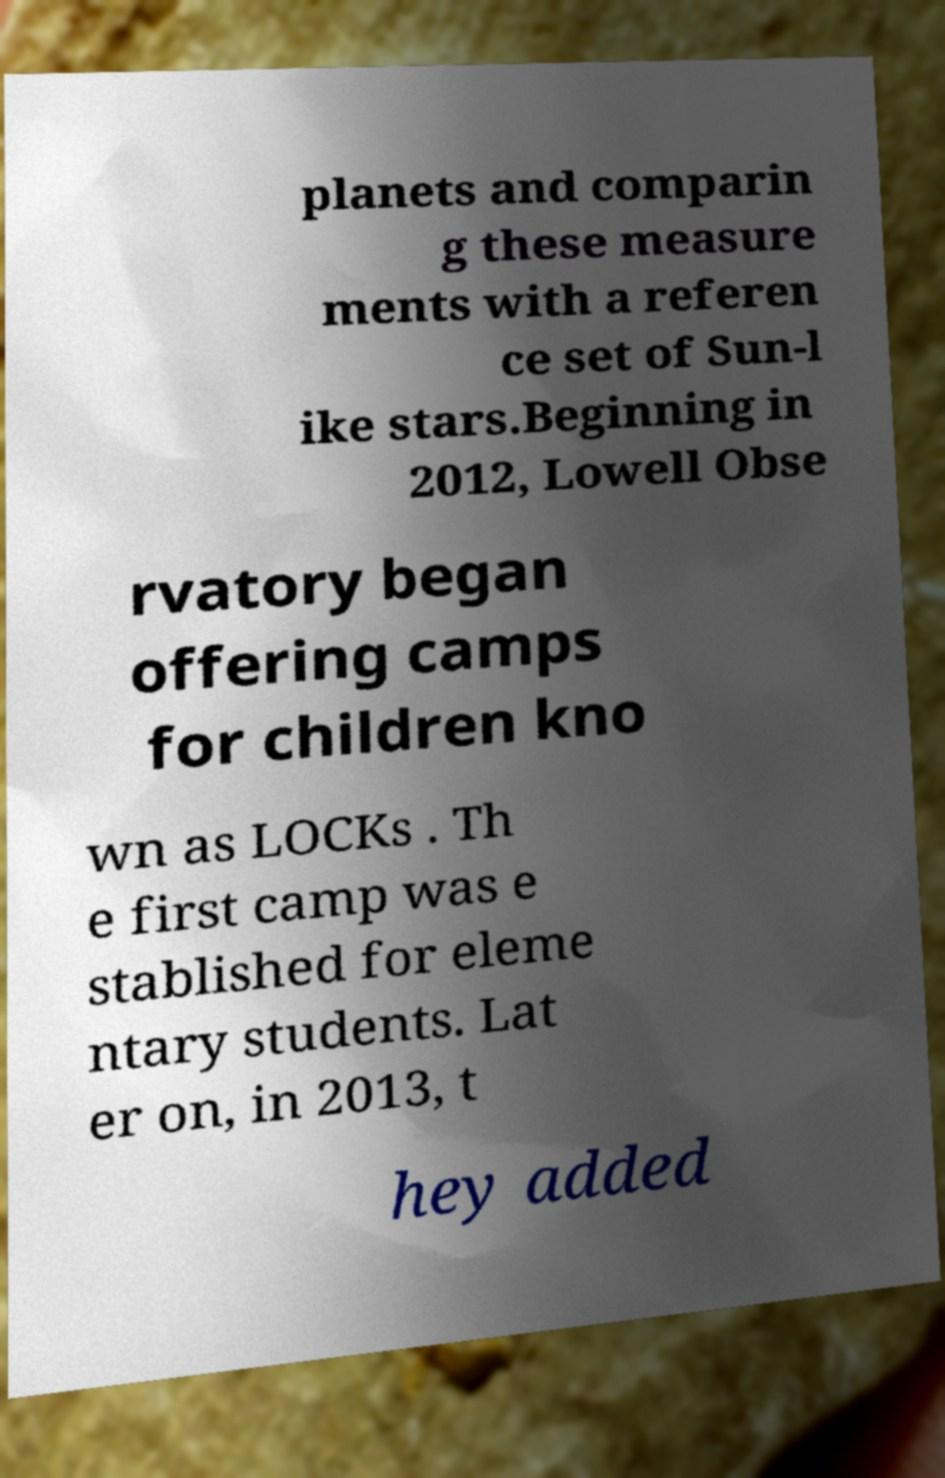Could you assist in decoding the text presented in this image and type it out clearly? planets and comparin g these measure ments with a referen ce set of Sun-l ike stars.Beginning in 2012, Lowell Obse rvatory began offering camps for children kno wn as LOCKs . Th e first camp was e stablished for eleme ntary students. Lat er on, in 2013, t hey added 